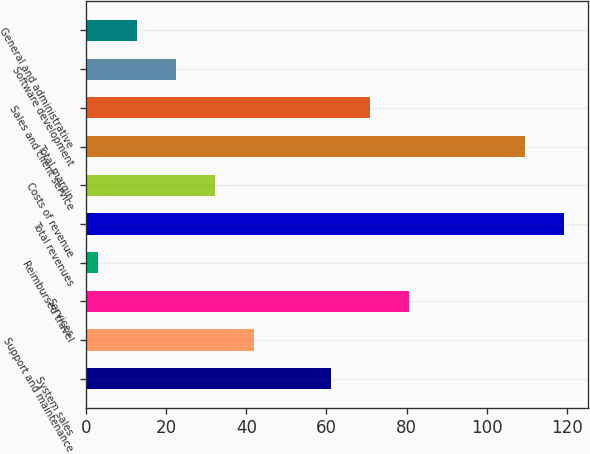Convert chart. <chart><loc_0><loc_0><loc_500><loc_500><bar_chart><fcel>System sales<fcel>Support and maintenance<fcel>Services<fcel>Reimbursed travel<fcel>Total revenues<fcel>Costs of revenue<fcel>Total margin<fcel>Sales and client service<fcel>Software development<fcel>General and administrative<nl><fcel>61.2<fcel>41.8<fcel>80.6<fcel>3<fcel>119.4<fcel>32.1<fcel>109.7<fcel>70.9<fcel>22.4<fcel>12.7<nl></chart> 